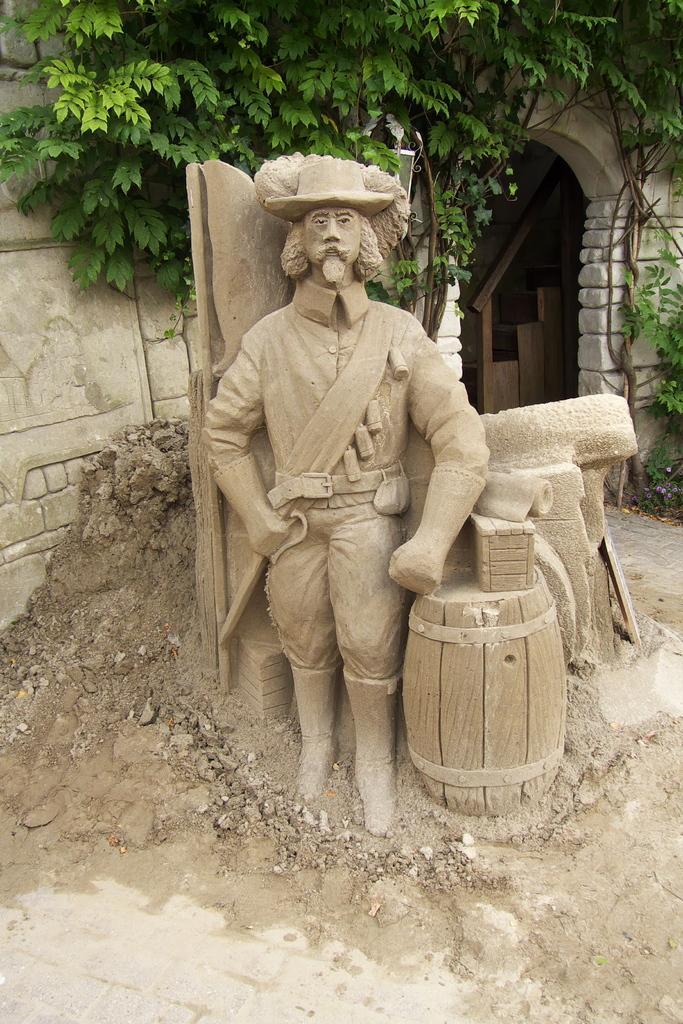In one or two sentences, can you explain what this image depicts? In this image we can see the statue of a person and to the side we can see some objects and in the background, we can see a building and trees. 